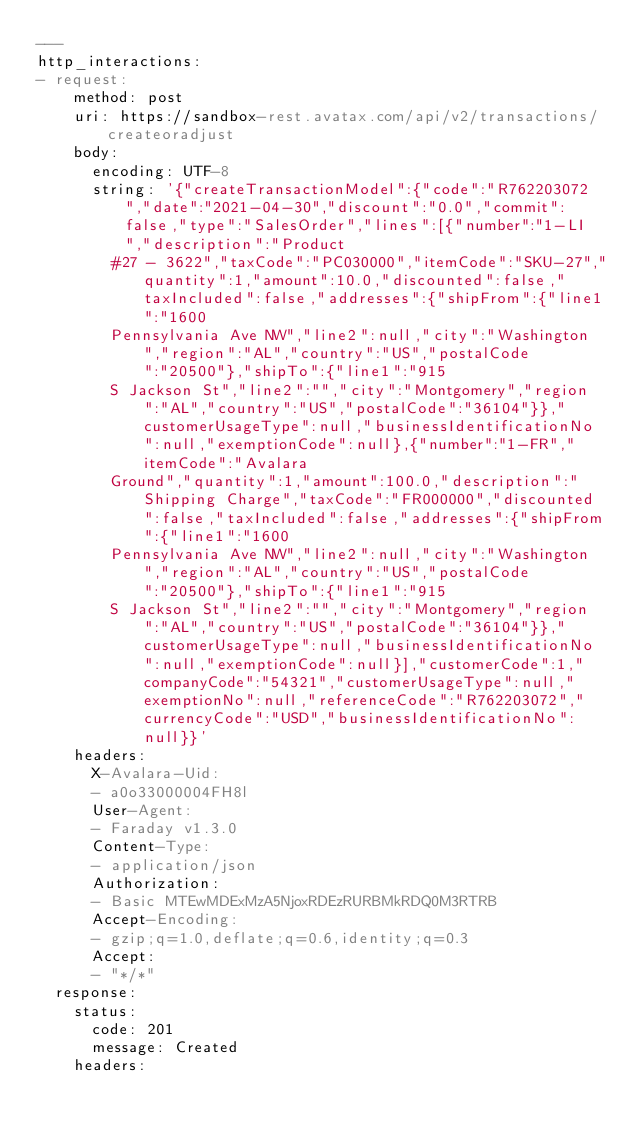<code> <loc_0><loc_0><loc_500><loc_500><_YAML_>---
http_interactions:
- request:
    method: post
    uri: https://sandbox-rest.avatax.com/api/v2/transactions/createoradjust
    body:
      encoding: UTF-8
      string: '{"createTransactionModel":{"code":"R762203072","date":"2021-04-30","discount":"0.0","commit":false,"type":"SalesOrder","lines":[{"number":"1-LI","description":"Product
        #27 - 3622","taxCode":"PC030000","itemCode":"SKU-27","quantity":1,"amount":10.0,"discounted":false,"taxIncluded":false,"addresses":{"shipFrom":{"line1":"1600
        Pennsylvania Ave NW","line2":null,"city":"Washington","region":"AL","country":"US","postalCode":"20500"},"shipTo":{"line1":"915
        S Jackson St","line2":"","city":"Montgomery","region":"AL","country":"US","postalCode":"36104"}},"customerUsageType":null,"businessIdentificationNo":null,"exemptionCode":null},{"number":"1-FR","itemCode":"Avalara
        Ground","quantity":1,"amount":100.0,"description":"Shipping Charge","taxCode":"FR000000","discounted":false,"taxIncluded":false,"addresses":{"shipFrom":{"line1":"1600
        Pennsylvania Ave NW","line2":null,"city":"Washington","region":"AL","country":"US","postalCode":"20500"},"shipTo":{"line1":"915
        S Jackson St","line2":"","city":"Montgomery","region":"AL","country":"US","postalCode":"36104"}},"customerUsageType":null,"businessIdentificationNo":null,"exemptionCode":null}],"customerCode":1,"companyCode":"54321","customerUsageType":null,"exemptionNo":null,"referenceCode":"R762203072","currencyCode":"USD","businessIdentificationNo":null}}'
    headers:
      X-Avalara-Uid:
      - a0o33000004FH8l
      User-Agent:
      - Faraday v1.3.0
      Content-Type:
      - application/json
      Authorization:
      - Basic MTEwMDExMzA5NjoxRDEzRURBMkRDQ0M3RTRB
      Accept-Encoding:
      - gzip;q=1.0,deflate;q=0.6,identity;q=0.3
      Accept:
      - "*/*"
  response:
    status:
      code: 201
      message: Created
    headers:</code> 